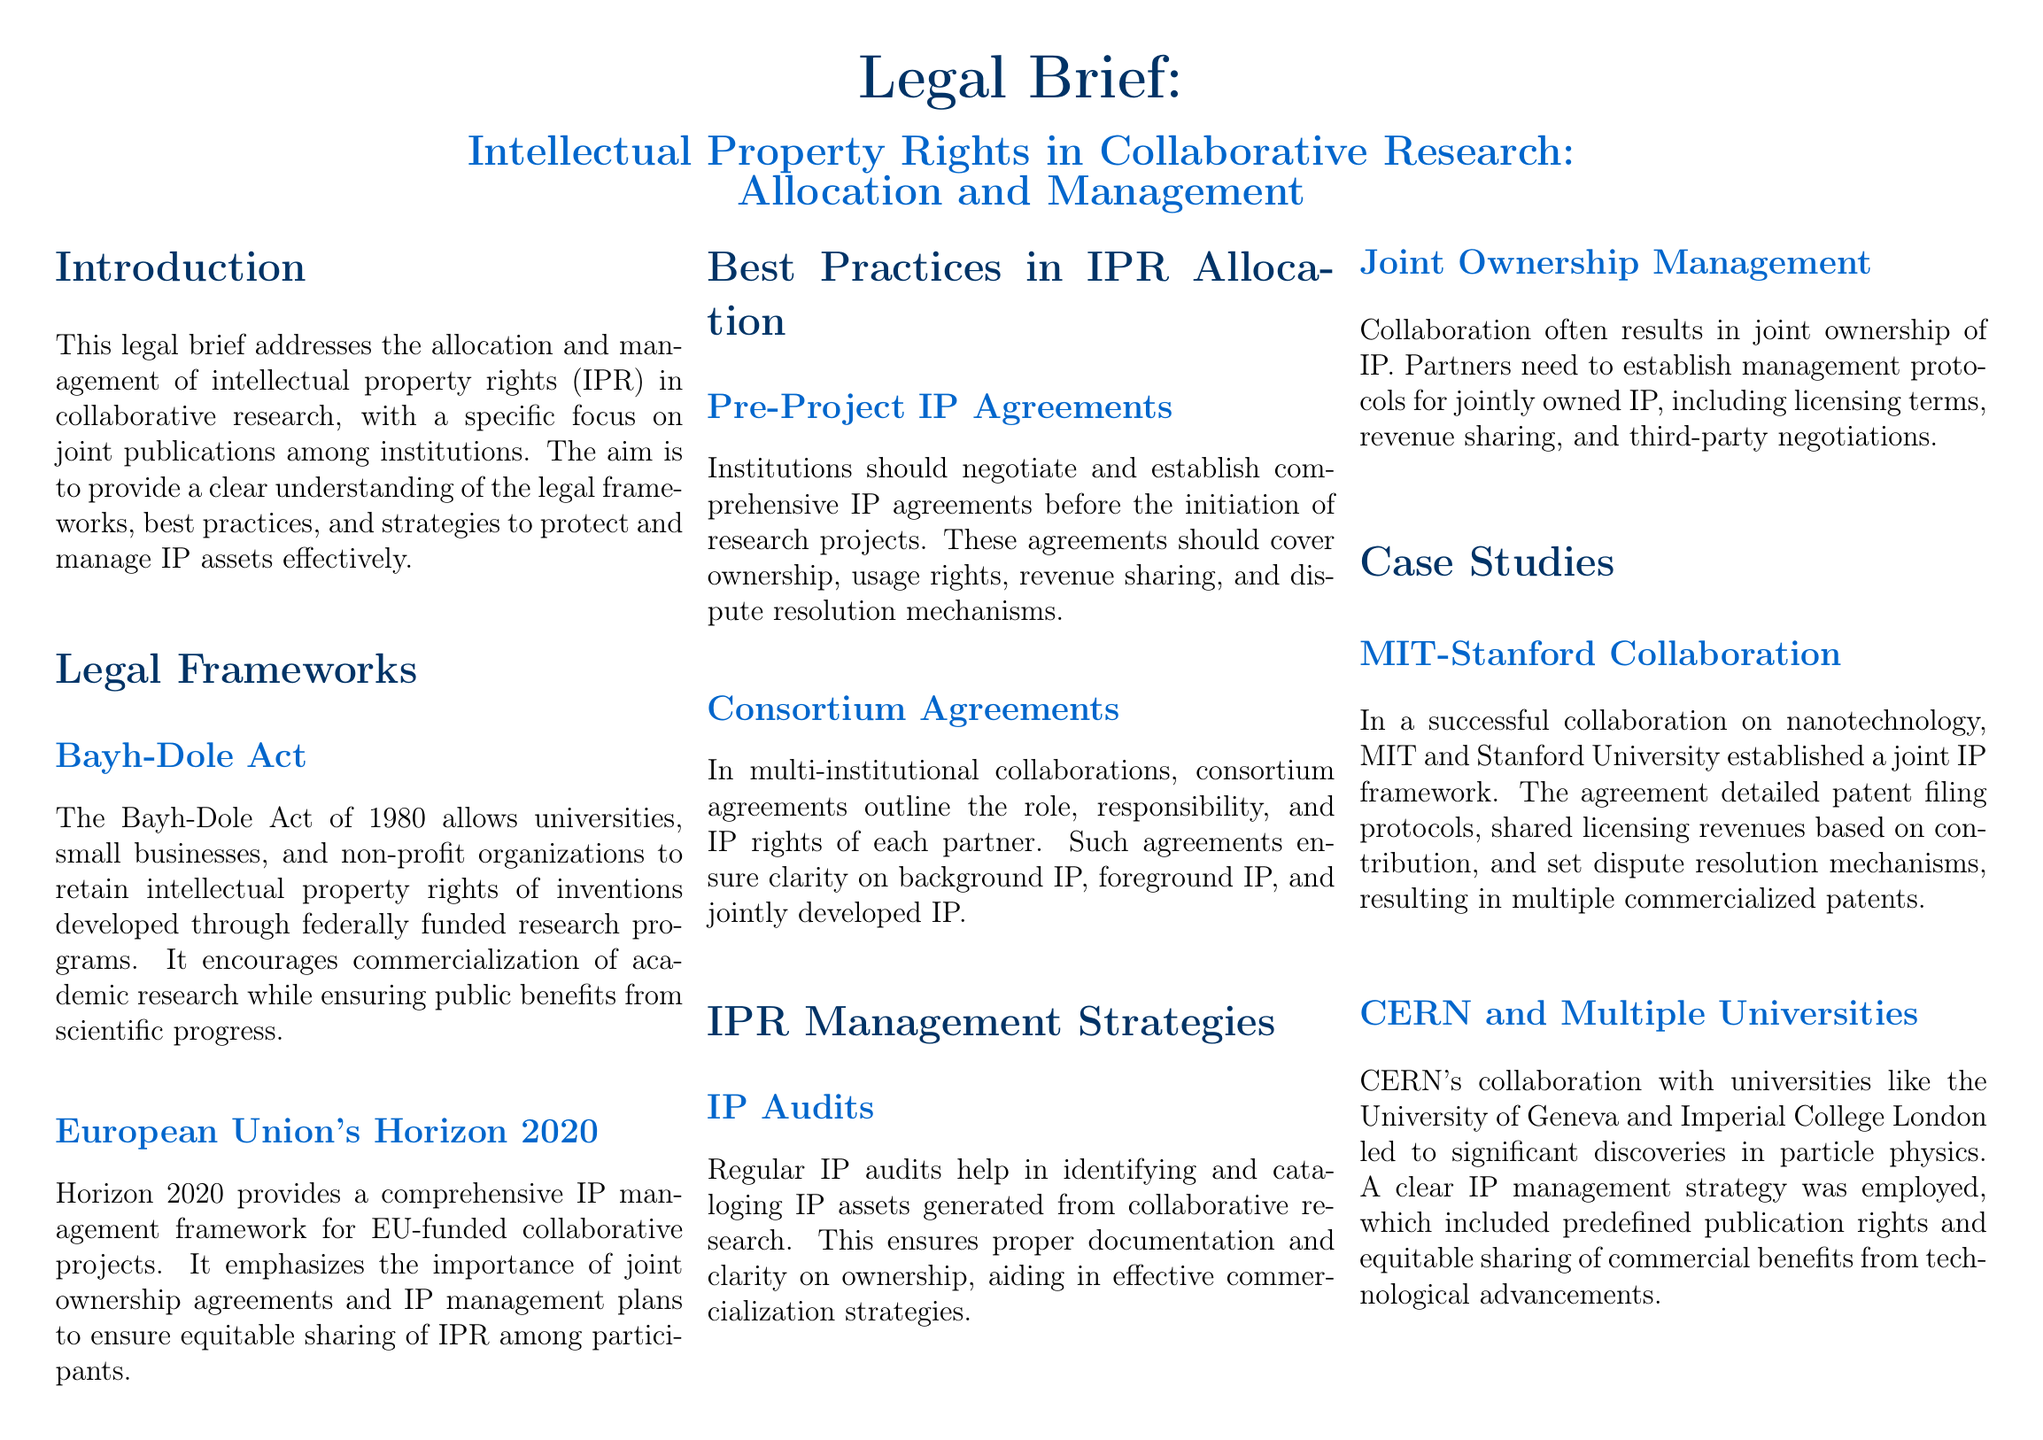What is the main focus of this legal brief? The brief addresses the allocation and management of intellectual property rights in collaborative research, particularly focusing on joint publications among institutions.
Answer: Allocation and management of intellectual property rights Which act allows universities to retain intellectual property rights? The Bayh-Dole Act allows universities to retain rights of inventions developed through federally funded research programs.
Answer: Bayh-Dole Act What is one of the case studies mentioned in the brief? The brief includes a case study of a collaboration between MIT and Stanford University that established a joint IP framework.
Answer: MIT-Stanford Collaboration What is emphasized by Horizon 2020 regarding IP management? Horizon 2020 emphasizes the importance of joint ownership agreements and IP management plans for equitable sharing of intellectual property rights.
Answer: Joint ownership agreements What should institutions negotiate before starting research projects? Institutions should negotiate comprehensive IP agreements covering ownership, usage rights, revenue sharing, and dispute resolution mechanisms.
Answer: Comprehensive IP agreements What type of audits are suggested for identifying IP assets? Regular IP audits are suggested to help identify and catalog IP assets generated from collaborative research.
Answer: Regular IP audits What management strategy is recommended for jointly owned IP? The document recommends establishing management protocols for jointly owned IP, including licensing terms and revenue sharing.
Answer: Management protocols What does the MIT-Stanford agreement detail? The agreement details patent filing protocols, shared licensing revenues based on contribution, and dispute resolution mechanisms.
Answer: Patent filing protocols What collaborative advantage is highlighted in the CERN case? CERN’s collaboration with universities resulted in predefined publication rights and equitable sharing of commercial benefits.
Answer: Equitable sharing of commercial benefits 